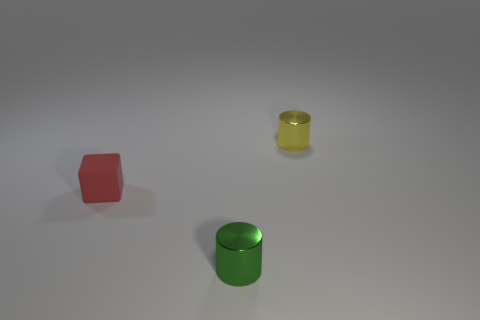Add 1 big brown rubber cylinders. How many objects exist? 4 Subtract all cylinders. How many objects are left? 1 Add 2 red rubber things. How many red rubber things exist? 3 Subtract 0 red cylinders. How many objects are left? 3 Subtract all small cyan rubber cubes. Subtract all green things. How many objects are left? 2 Add 3 yellow metallic cylinders. How many yellow metallic cylinders are left? 4 